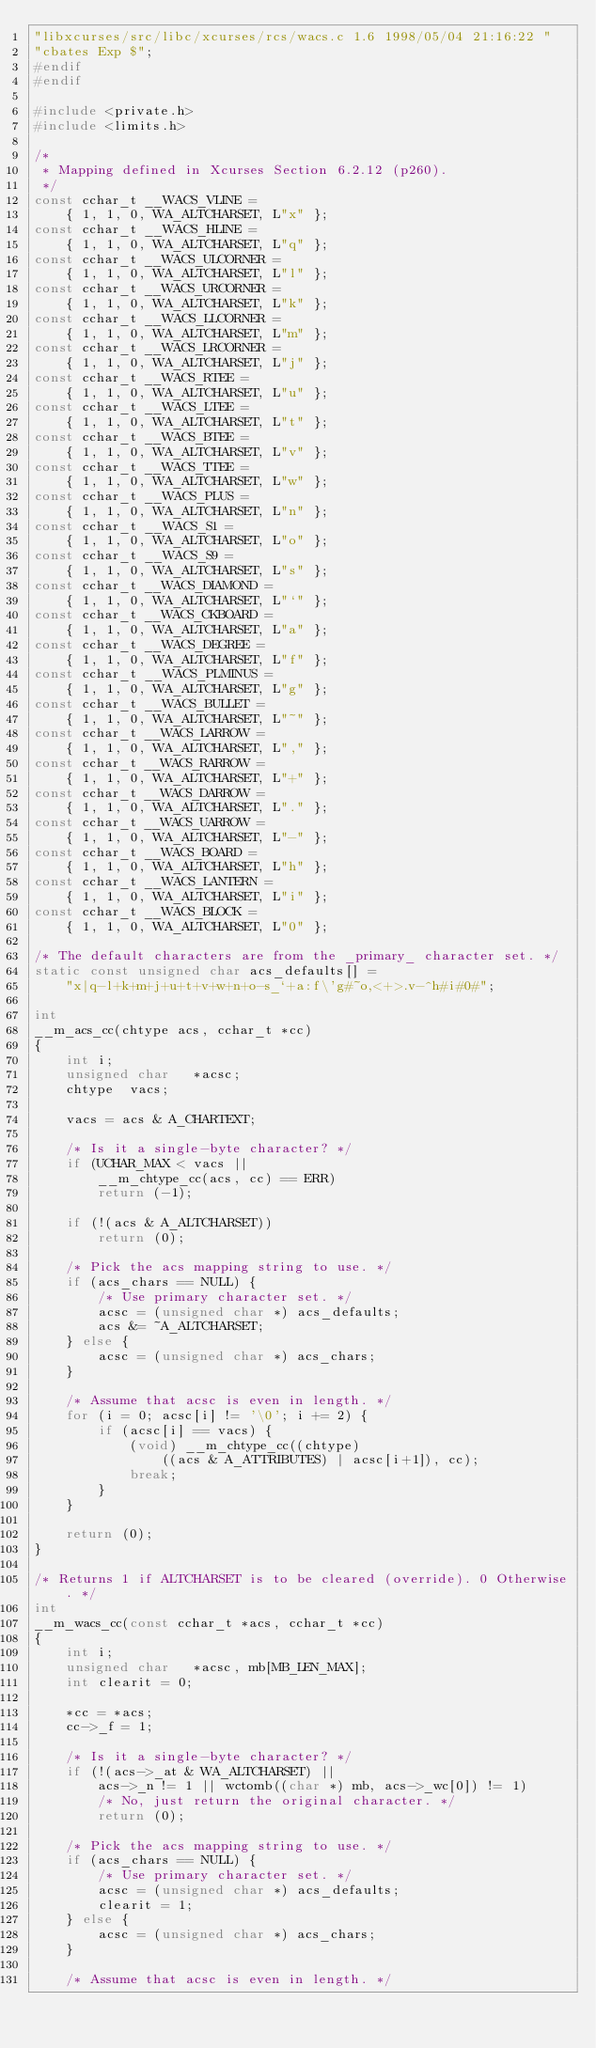<code> <loc_0><loc_0><loc_500><loc_500><_C_>"libxcurses/src/libc/xcurses/rcs/wacs.c 1.6 1998/05/04 21:16:22 "
"cbates Exp $";
#endif
#endif

#include <private.h>
#include <limits.h>

/*
 * Mapping defined in Xcurses Section 6.2.12 (p260).
 */
const cchar_t __WACS_VLINE =
	{ 1, 1, 0, WA_ALTCHARSET, L"x" };
const cchar_t __WACS_HLINE =
	{ 1, 1, 0, WA_ALTCHARSET, L"q" };
const cchar_t __WACS_ULCORNER =
	{ 1, 1, 0, WA_ALTCHARSET, L"l" };
const cchar_t __WACS_URCORNER =
	{ 1, 1, 0, WA_ALTCHARSET, L"k" };
const cchar_t __WACS_LLCORNER =
	{ 1, 1, 0, WA_ALTCHARSET, L"m" };
const cchar_t __WACS_LRCORNER =
	{ 1, 1, 0, WA_ALTCHARSET, L"j" };
const cchar_t __WACS_RTEE =
	{ 1, 1, 0, WA_ALTCHARSET, L"u" };
const cchar_t __WACS_LTEE =
	{ 1, 1, 0, WA_ALTCHARSET, L"t" };
const cchar_t __WACS_BTEE =
	{ 1, 1, 0, WA_ALTCHARSET, L"v" };
const cchar_t __WACS_TTEE =
	{ 1, 1, 0, WA_ALTCHARSET, L"w" };
const cchar_t __WACS_PLUS =
	{ 1, 1, 0, WA_ALTCHARSET, L"n" };
const cchar_t __WACS_S1 =
	{ 1, 1, 0, WA_ALTCHARSET, L"o" };
const cchar_t __WACS_S9 =
	{ 1, 1, 0, WA_ALTCHARSET, L"s" };
const cchar_t __WACS_DIAMOND =
	{ 1, 1, 0, WA_ALTCHARSET, L"`" };
const cchar_t __WACS_CKBOARD =
	{ 1, 1, 0, WA_ALTCHARSET, L"a" };
const cchar_t __WACS_DEGREE =
	{ 1, 1, 0, WA_ALTCHARSET, L"f" };
const cchar_t __WACS_PLMINUS =
	{ 1, 1, 0, WA_ALTCHARSET, L"g" };
const cchar_t __WACS_BULLET =
	{ 1, 1, 0, WA_ALTCHARSET, L"~" };
const cchar_t __WACS_LARROW =
	{ 1, 1, 0, WA_ALTCHARSET, L"," };
const cchar_t __WACS_RARROW =
	{ 1, 1, 0, WA_ALTCHARSET, L"+" };
const cchar_t __WACS_DARROW =
	{ 1, 1, 0, WA_ALTCHARSET, L"." };
const cchar_t __WACS_UARROW =
	{ 1, 1, 0, WA_ALTCHARSET, L"-" };
const cchar_t __WACS_BOARD =
	{ 1, 1, 0, WA_ALTCHARSET, L"h" };
const cchar_t __WACS_LANTERN =
	{ 1, 1, 0, WA_ALTCHARSET, L"i" };
const cchar_t __WACS_BLOCK =
	{ 1, 1, 0, WA_ALTCHARSET, L"0" };

/* The default characters are from the _primary_ character set. */
static const unsigned char acs_defaults[] =
	"x|q-l+k+m+j+u+t+v+w+n+o-s_`+a:f\'g#~o,<+>.v-^h#i#0#";

int
__m_acs_cc(chtype acs, cchar_t *cc)
{
	int	i;
	unsigned char	*acsc;
	chtype	vacs;

	vacs = acs & A_CHARTEXT;

	/* Is it a single-byte character? */
	if (UCHAR_MAX < vacs ||
		__m_chtype_cc(acs, cc) == ERR)
		return (-1);

	if (!(acs & A_ALTCHARSET))
		return (0);

	/* Pick the acs mapping string to use. */
	if (acs_chars == NULL) {
		/* Use primary character set. */
		acsc = (unsigned char *) acs_defaults;
		acs &= ~A_ALTCHARSET;
	} else {
		acsc = (unsigned char *) acs_chars;
	}

	/* Assume that acsc is even in length. */
	for (i = 0; acsc[i] != '\0'; i += 2) {
		if (acsc[i] == vacs) {
			(void) __m_chtype_cc((chtype)
				((acs & A_ATTRIBUTES) | acsc[i+1]), cc);
			break;
		}
	}

	return (0);
}

/* Returns 1 if ALTCHARSET is to be cleared (override). 0 Otherwise. */
int
__m_wacs_cc(const cchar_t *acs, cchar_t *cc)
{
	int	i;
	unsigned char	*acsc, mb[MB_LEN_MAX];
	int	clearit = 0;

	*cc = *acs;
	cc->_f = 1;

	/* Is it a single-byte character? */
	if (!(acs->_at & WA_ALTCHARSET) ||
		acs->_n != 1 || wctomb((char *) mb, acs->_wc[0]) != 1)
		/* No, just return the original character. */
		return (0);

	/* Pick the acs mapping string to use. */
	if (acs_chars == NULL) {
		/* Use primary character set. */
		acsc = (unsigned char *) acs_defaults;
		clearit = 1;
	} else {
		acsc = (unsigned char *) acs_chars;
	}

	/* Assume that acsc is even in length. */</code> 